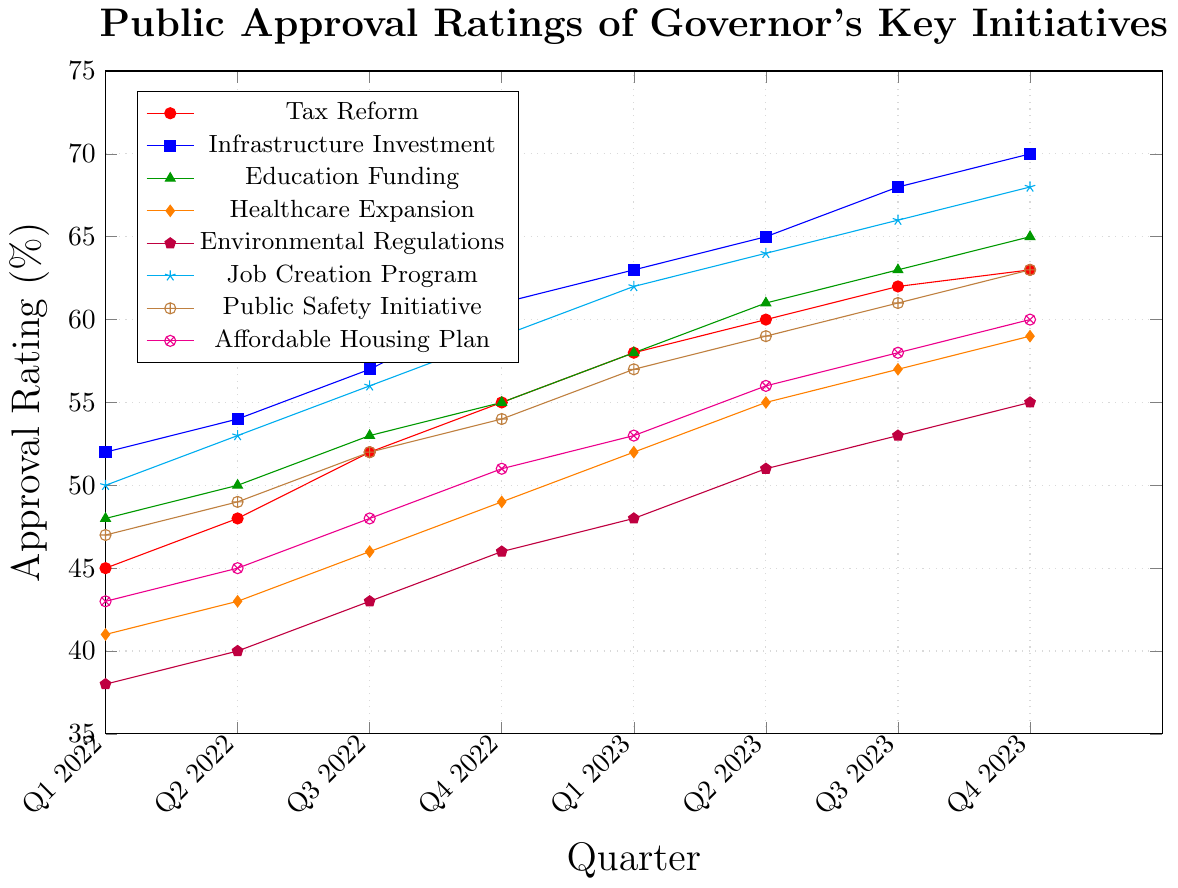What's the highest approval rating achieved for the Infrastructure Investment initiative? Locate the Infrastructure Investment line, which is blue, on the chart. The highest approval rating is at Q4 2023, where it reaches 70%.
Answer: 70% Which initiative had the lowest approval rating in Q1 2022? Compare the starting points of all initiatives at Q1 2022. The Environmental Regulations initiative, shown by the purple line, has the lowest approval rating of 38%.
Answer: Environmental Regulations How much did the approval rating for the Tax Reform initiative increase from Q1 2023 to Q4 2023? Locate the Tax Reform initiative (red line) and compare the ratings at Q1 2023 (58%) and Q4 2023 (63%). The difference is 63% - 58% = 5%.
Answer: 5% Which initiative had the most consistent increase in approval rating from Q1 2022 to Q4 2023? Check which line has the steadiest upward trend without significant fluctuations. The Infrastructure Investment initiative (blue line) shows a steady increase from 52% to 70%.
Answer: Infrastructure Investment What is the average approval rating for the Healthcare Expansion initiative over the eight quarters? Sum the approval ratings of Healthcare Expansion (orange line) over all quarters: (41 + 43 + 46 + 49 + 52 + 55 + 57 + 59) = 402. Then, divide by the number of quarters (8): 402 / 8 = 50.25.
Answer: 50.25% Compare the approval rating of the Affordable Housing Plan in Q4 2022 against the Job Creation Program in Q2 2023. Which one is higher? The Affordable Housing Plan (brown line) is at 51% in Q4 2022, and the Job Creation Program (cyan line) is at 64% in Q2 2023. Thus, Job Creation Program in Q2 2023 is higher.
Answer: Job Creation Program in Q2 2023 Which initiative showed a greater increase in approval ratings from Q2 2022 to Q4 2023, Education Funding or Public Safety Initiative? Calculate the difference for both initiatives. Education Funding (green line) increased from 50% to 65%: 65% - 50% = 15%. Public Safety Initiative (brown line) increased from 49% to 63%: 63% - 49% = 14%. The Education Funding initiative had a greater increase.
Answer: Education Funding Combining the approval ratings of Q3 2022, which initiative has the highest combined approval rating? Sum the approval ratings of Q3 2022 for all initiatives: Tax Reform (52), Infrastructure Investment (57), Education Funding (53), Healthcare Expansion (46), Environmental Regulations (43), Job Creation Program (56), Public Safety Initiative (52), Affordable Housing Plan (48). The initiative with the individual highest rating among these is Infrastructure Investment with 57.
Answer: Infrastructure Investment In which quarter did the Public Safety Initiative first reach an approval rating of at least 60%? Follow the Public Safety Initiative line (brown line) and identify the quarter when it first hits or exceeds 60%. This occurs in Q3 2023 when it reaches 61%.
Answer: Q3 2023 